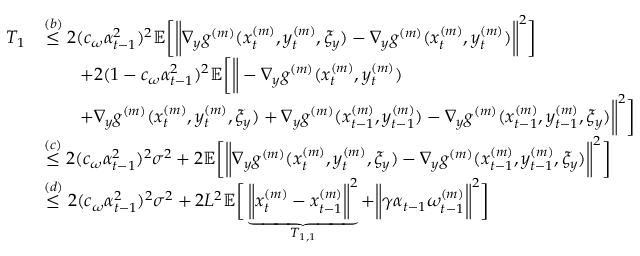Convert formula to latex. <formula><loc_0><loc_0><loc_500><loc_500>\begin{array} { r l } { T _ { 1 } } & { \overset { ( b ) } { \leq } 2 ( c _ { \omega } \alpha _ { t - 1 } ^ { 2 } ) ^ { 2 } \mathbb { E } \left [ \left \| \nabla _ { y } g ^ { ( m ) } ( x _ { t } ^ { ( m ) } , y _ { t } ^ { ( m ) } , \xi _ { y } ) - \nabla _ { y } g ^ { ( m ) } ( x _ { t } ^ { ( m ) } , y _ { t } ^ { ( m ) } ) \right \| ^ { 2 } \right ] } \\ & { \quad + 2 ( 1 - c _ { \omega } \alpha _ { t - 1 } ^ { 2 } ) ^ { 2 } \mathbb { E } \left [ \left \| - \nabla _ { y } g ^ { ( m ) } ( x _ { t } ^ { ( m ) } , y _ { t } ^ { ( m ) } ) } \\ & { \quad + \nabla _ { y } g ^ { ( m ) } ( x _ { t } ^ { ( m ) } , y _ { t } ^ { ( m ) } , \xi _ { y } ) + \nabla _ { y } g ^ { ( m ) } ( x _ { t - 1 } ^ { ( m ) } , y _ { t - 1 } ^ { ( m ) } ) - \nabla _ { y } g ^ { ( m ) } ( x _ { t - 1 } ^ { ( m ) } , y _ { t - 1 } ^ { ( m ) } , \xi _ { y } ) \right \| ^ { 2 } \right ] } \\ & { \overset { ( c ) } { \leq } 2 ( c _ { \omega } \alpha _ { t - 1 } ^ { 2 } ) ^ { 2 } \sigma ^ { 2 } + 2 \mathbb { E } \left [ \left \| \nabla _ { y } g ^ { ( m ) } ( x _ { t } ^ { ( m ) } , y _ { t } ^ { ( m ) } , \xi _ { y } ) - \nabla _ { y } g ^ { ( m ) } ( x _ { t - 1 } ^ { ( m ) } , y _ { t - 1 } ^ { ( m ) } , \xi _ { y } ) \right \| ^ { 2 } \right ] } \\ & { \overset { ( d ) } { \leq } 2 ( c _ { \omega } \alpha _ { t - 1 } ^ { 2 } ) ^ { 2 } \sigma ^ { 2 } + 2 L ^ { 2 } \mathbb { E } \left [ \underbrace { \left \| x _ { t } ^ { ( m ) } - x _ { t - 1 } ^ { ( m ) } \right \| ^ { 2 } } _ { T _ { 1 , 1 } } + \left \| \gamma \alpha _ { t - 1 } \omega _ { t - 1 } ^ { ( m ) } \right \| ^ { 2 } \right ] } \end{array}</formula> 